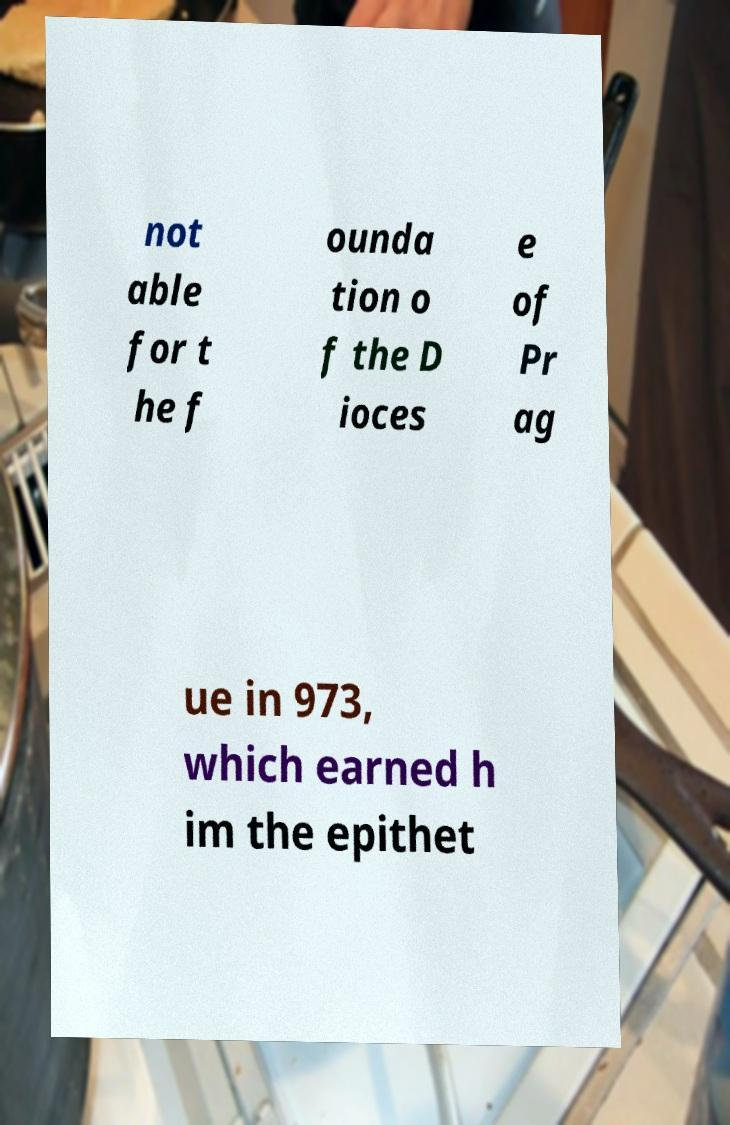For documentation purposes, I need the text within this image transcribed. Could you provide that? not able for t he f ounda tion o f the D ioces e of Pr ag ue in 973, which earned h im the epithet 